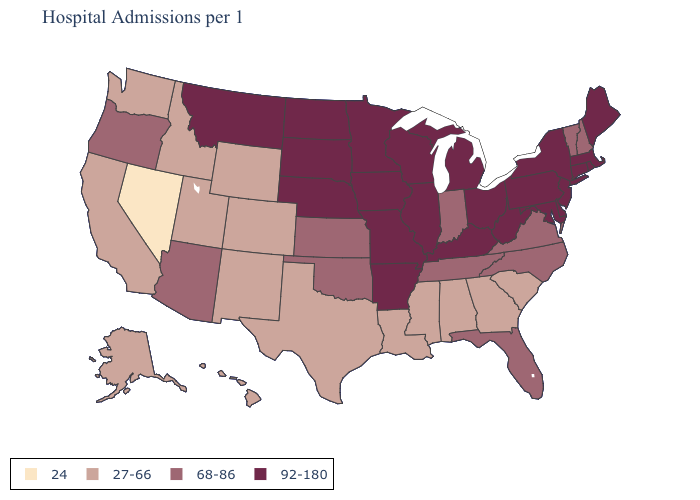Does the map have missing data?
Concise answer only. No. Which states have the lowest value in the USA?
Quick response, please. Nevada. Name the states that have a value in the range 92-180?
Give a very brief answer. Arkansas, Connecticut, Delaware, Illinois, Iowa, Kentucky, Maine, Maryland, Massachusetts, Michigan, Minnesota, Missouri, Montana, Nebraska, New Jersey, New York, North Dakota, Ohio, Pennsylvania, Rhode Island, South Dakota, West Virginia, Wisconsin. How many symbols are there in the legend?
Write a very short answer. 4. Does the first symbol in the legend represent the smallest category?
Be succinct. Yes. Does Wyoming have a lower value than Utah?
Short answer required. No. Name the states that have a value in the range 27-66?
Write a very short answer. Alabama, Alaska, California, Colorado, Georgia, Hawaii, Idaho, Louisiana, Mississippi, New Mexico, South Carolina, Texas, Utah, Washington, Wyoming. What is the value of Arkansas?
Quick response, please. 92-180. Does Alaska have the highest value in the USA?
Answer briefly. No. What is the highest value in the West ?
Answer briefly. 92-180. Does the map have missing data?
Write a very short answer. No. What is the lowest value in the USA?
Give a very brief answer. 24. Which states have the highest value in the USA?
Concise answer only. Arkansas, Connecticut, Delaware, Illinois, Iowa, Kentucky, Maine, Maryland, Massachusetts, Michigan, Minnesota, Missouri, Montana, Nebraska, New Jersey, New York, North Dakota, Ohio, Pennsylvania, Rhode Island, South Dakota, West Virginia, Wisconsin. What is the highest value in states that border Minnesota?
Short answer required. 92-180. Among the states that border Tennessee , does Missouri have the lowest value?
Be succinct. No. 